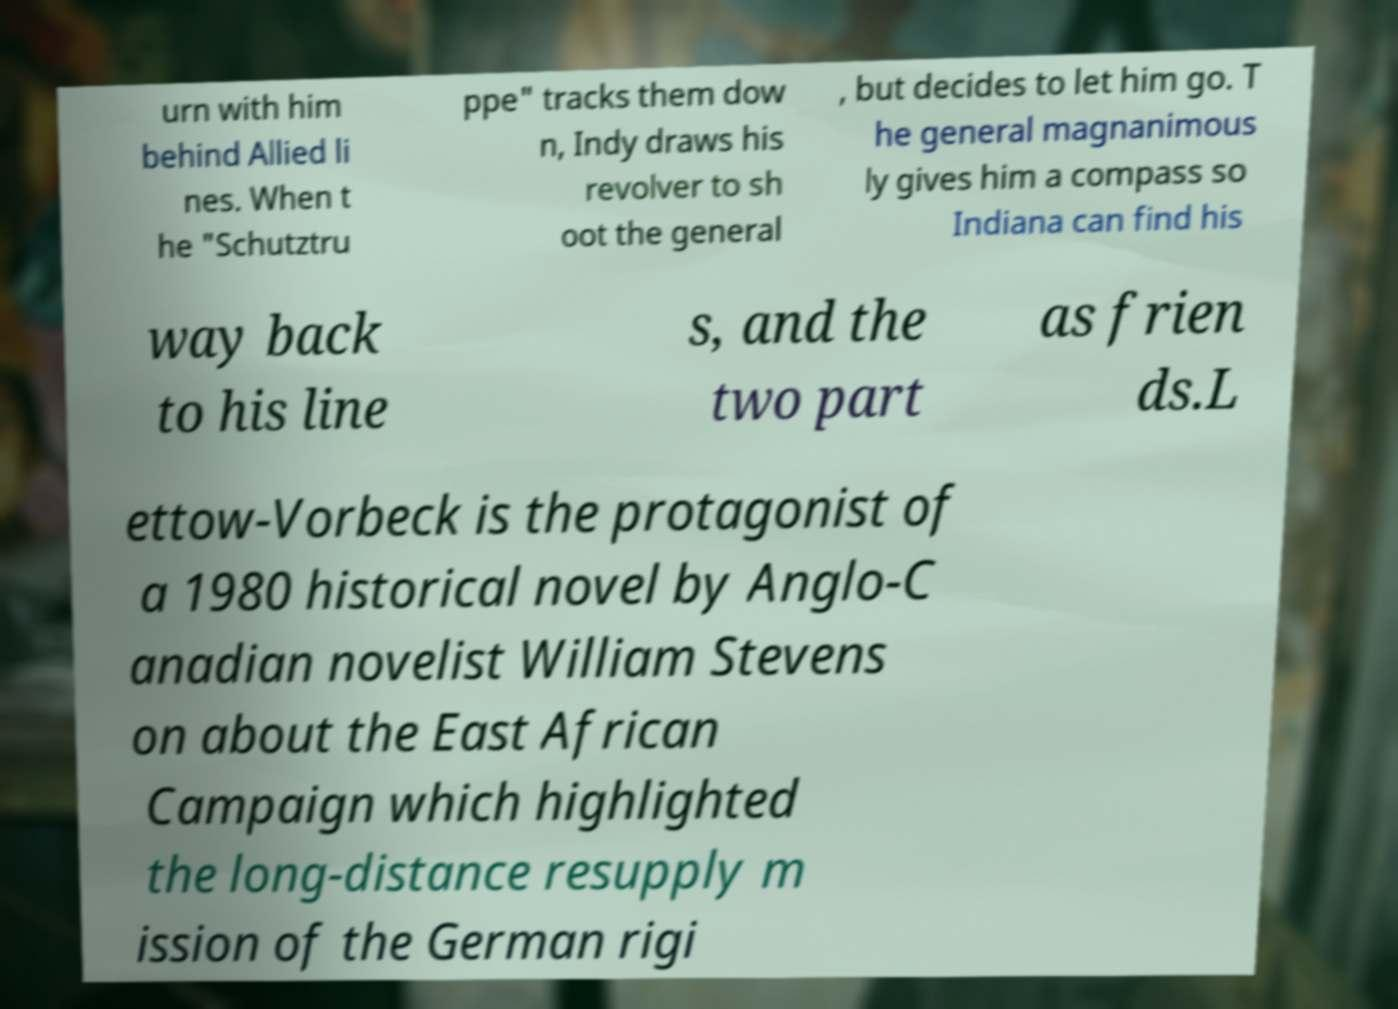For documentation purposes, I need the text within this image transcribed. Could you provide that? urn with him behind Allied li nes. When t he "Schutztru ppe" tracks them dow n, Indy draws his revolver to sh oot the general , but decides to let him go. T he general magnanimous ly gives him a compass so Indiana can find his way back to his line s, and the two part as frien ds.L ettow-Vorbeck is the protagonist of a 1980 historical novel by Anglo-C anadian novelist William Stevens on about the East African Campaign which highlighted the long-distance resupply m ission of the German rigi 